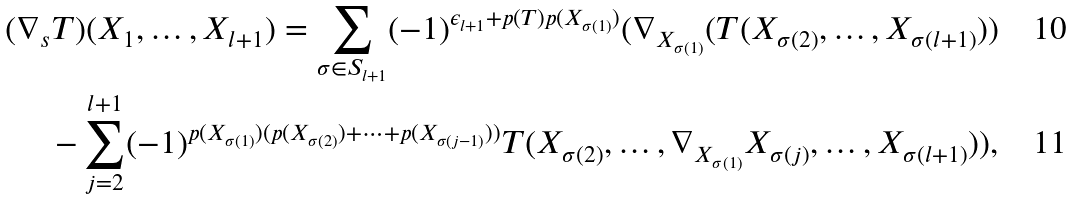Convert formula to latex. <formula><loc_0><loc_0><loc_500><loc_500>( \nabla _ { s } T ) ( X _ { 1 } , \dots , X _ { l + 1 } ) = \sum _ { \sigma \in S _ { l + 1 } } ( - 1 ) ^ { \epsilon _ { l + 1 } + p ( T ) p ( X _ { \sigma ( 1 ) } ) } ( \nabla _ { X _ { \sigma ( 1 ) } } ( T ( X _ { \sigma ( 2 ) } , \dots , X _ { \sigma ( l + 1 ) } ) ) \\ - \sum _ { j = 2 } ^ { l + 1 } ( - 1 ) ^ { p ( X _ { \sigma ( 1 ) } ) ( p ( X _ { \sigma ( 2 ) } ) + \cdots + p ( X _ { \sigma ( j - 1 ) } ) ) } T ( X _ { \sigma ( 2 ) } , \dots , \nabla _ { X _ { \sigma ( 1 ) } } X _ { \sigma ( j ) } , \dots , X _ { \sigma ( l + 1 ) } ) ) ,</formula> 